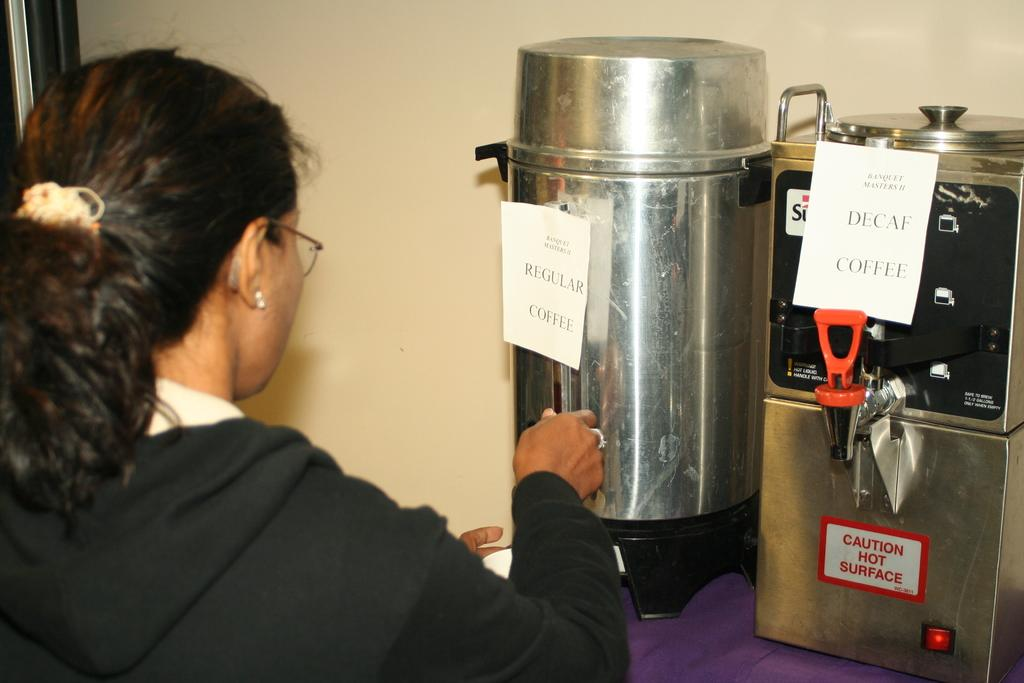<image>
Give a short and clear explanation of the subsequent image. A woman gets coffee from the regular coffee urn. 